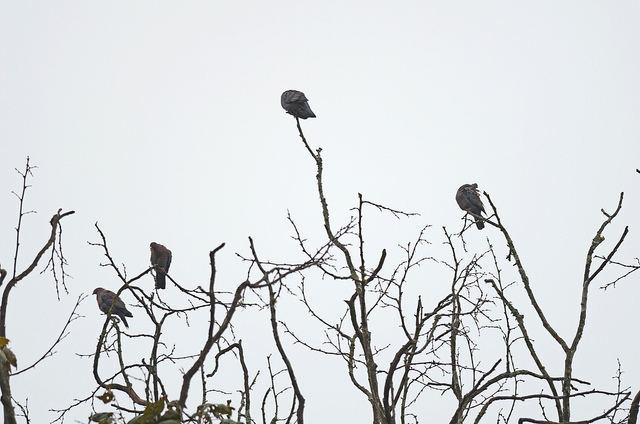<image>What is the birds breast? It's unclear what color the bird's breast is, as it could be blue, black, or red. What is the birds breast? I don't know what is the bird's breast. It can be feathers, chest or body part. 